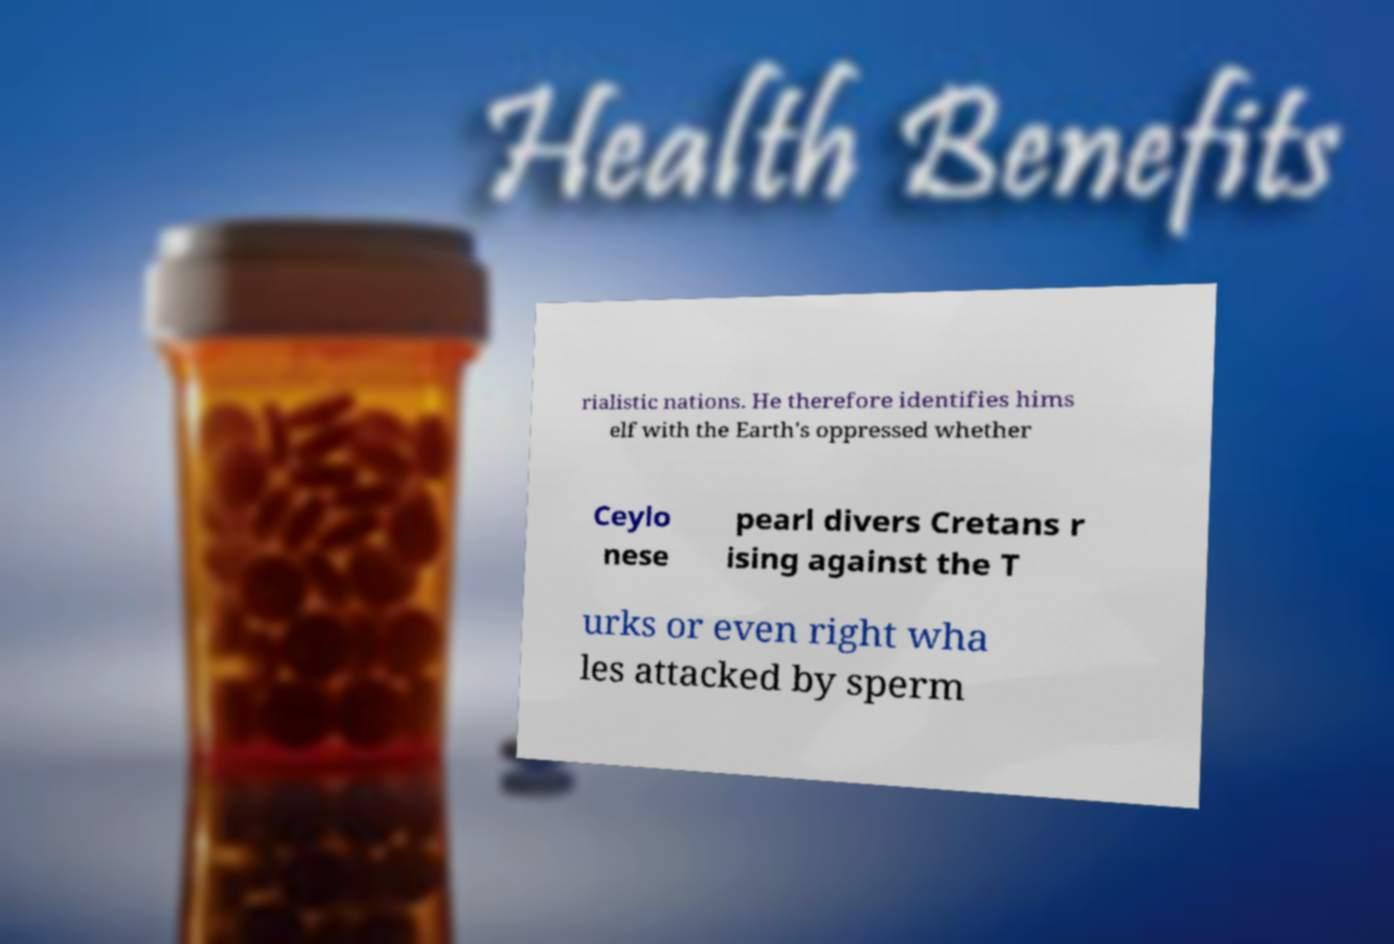I need the written content from this picture converted into text. Can you do that? rialistic nations. He therefore identifies hims elf with the Earth's oppressed whether Ceylo nese pearl divers Cretans r ising against the T urks or even right wha les attacked by sperm 